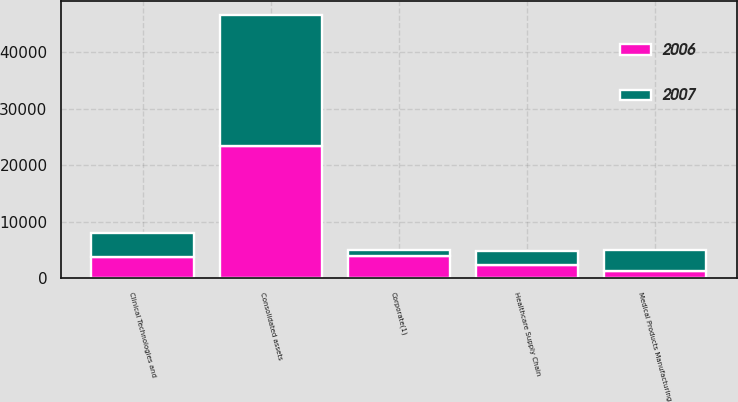<chart> <loc_0><loc_0><loc_500><loc_500><stacked_bar_chart><ecel><fcel>Healthcare Supply Chain<fcel>Clinical Technologies and<fcel>Medical Products Manufacturing<fcel>Corporate(1)<fcel>Consolidated assets<nl><fcel>2007<fcel>2472.9<fcel>4273<fcel>3604.2<fcel>1098.5<fcel>23153.8<nl><fcel>2006<fcel>2425.8<fcel>3721.3<fcel>1397.1<fcel>3911.5<fcel>23433.3<nl></chart> 